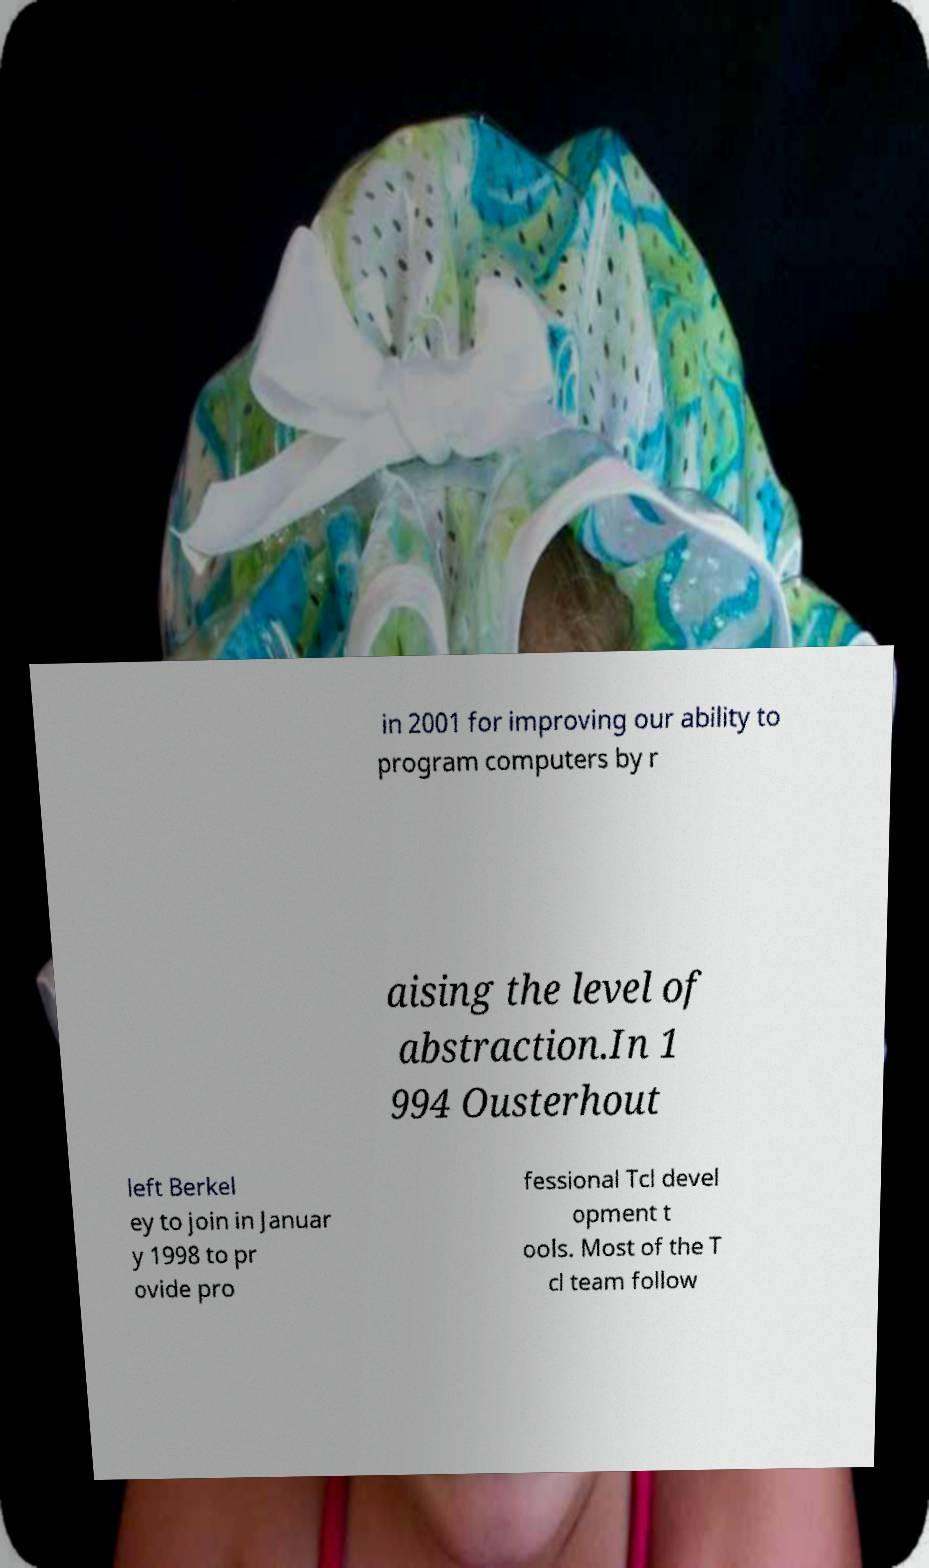For documentation purposes, I need the text within this image transcribed. Could you provide that? in 2001 for improving our ability to program computers by r aising the level of abstraction.In 1 994 Ousterhout left Berkel ey to join in Januar y 1998 to pr ovide pro fessional Tcl devel opment t ools. Most of the T cl team follow 